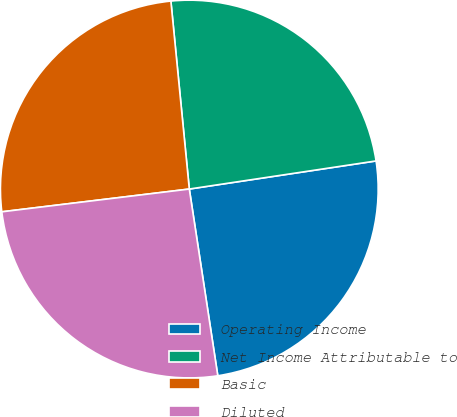Convert chart to OTSL. <chart><loc_0><loc_0><loc_500><loc_500><pie_chart><fcel>Operating Income<fcel>Net Income Attributable to<fcel>Basic<fcel>Diluted<nl><fcel>24.97%<fcel>24.18%<fcel>25.37%<fcel>25.49%<nl></chart> 